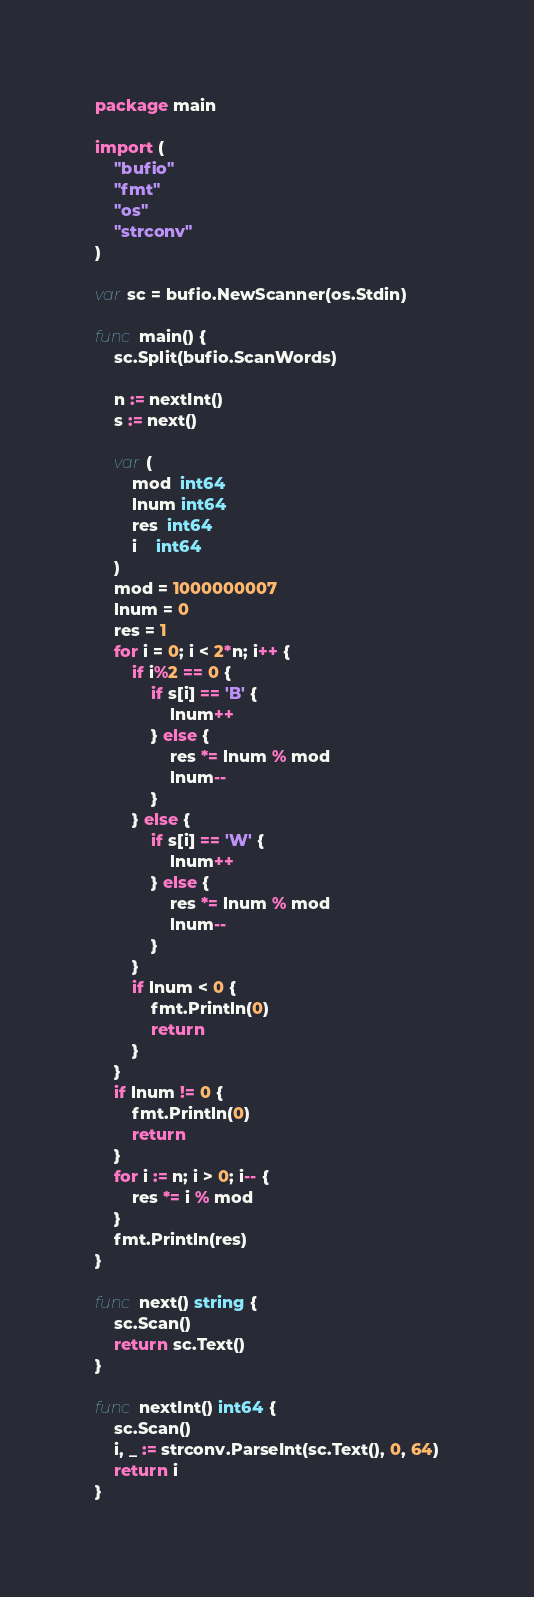<code> <loc_0><loc_0><loc_500><loc_500><_Go_>package main

import (
	"bufio"
	"fmt"
	"os"
	"strconv"
)

var sc = bufio.NewScanner(os.Stdin)

func main() {
	sc.Split(bufio.ScanWords)

	n := nextInt()
	s := next()

	var (
		mod  int64
		lnum int64
		res  int64
		i    int64
	)
	mod = 1000000007
	lnum = 0
	res = 1
	for i = 0; i < 2*n; i++ {
		if i%2 == 0 {
			if s[i] == 'B' {
				lnum++
			} else {
				res *= lnum % mod
				lnum--
			}
		} else {
			if s[i] == 'W' {
				lnum++
			} else {
				res *= lnum % mod
				lnum--
			}
		}
		if lnum < 0 {
			fmt.Println(0)
			return
		}
	}
	if lnum != 0 {
		fmt.Println(0)
		return
	}
	for i := n; i > 0; i-- {
		res *= i % mod
	}
	fmt.Println(res)
}

func next() string {
	sc.Scan()
	return sc.Text()
}

func nextInt() int64 {
	sc.Scan()
	i, _ := strconv.ParseInt(sc.Text(), 0, 64)
	return i
}
</code> 